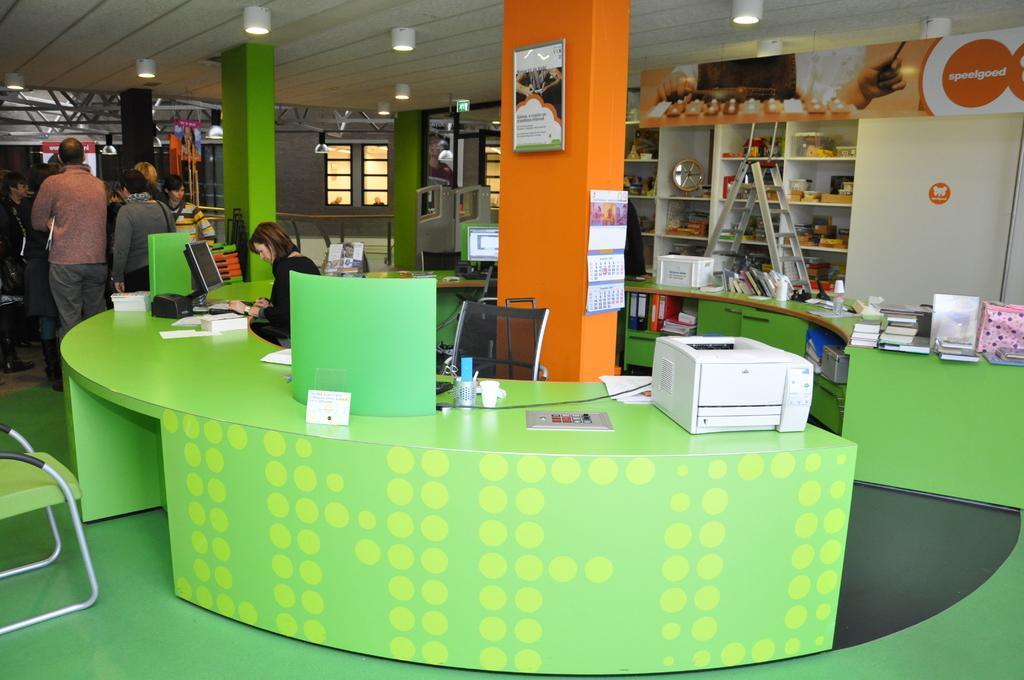In one or two sentences, can you explain what this image depicts? In this image we can see some people, table, laptop, printer, chairs, racks filled with some objects, pillars, lights and we can also see the windows. 